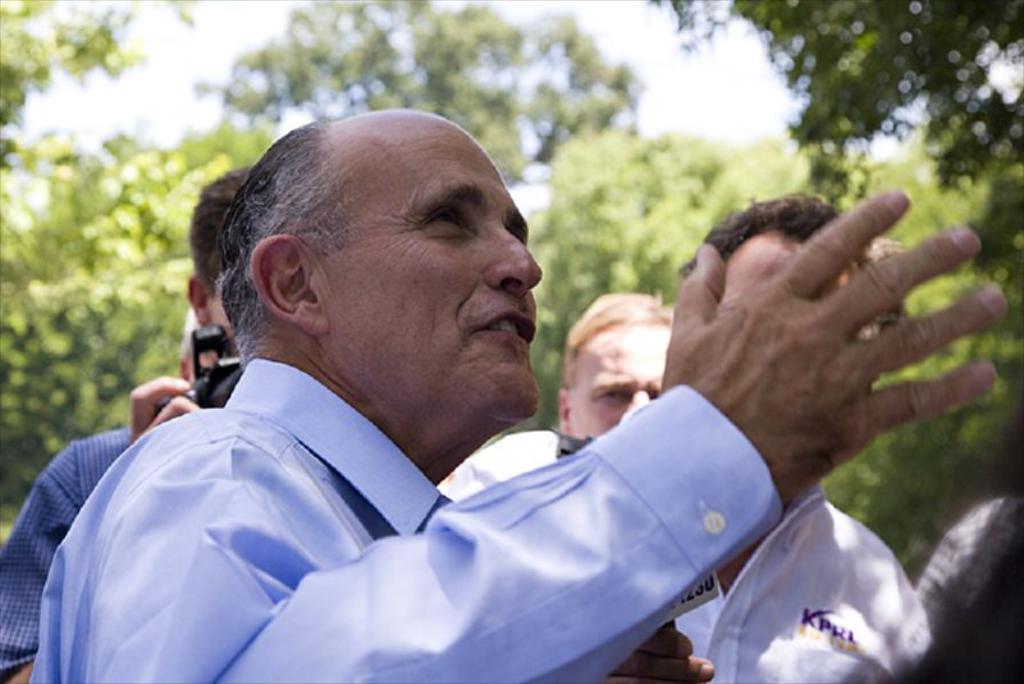Please provide a concise description of this image. In this image, I can see a group of people. In the background, there are trees and the sky. 